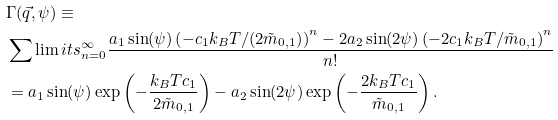<formula> <loc_0><loc_0><loc_500><loc_500>& \Gamma ( \vec { q } , \psi ) \equiv \\ & \sum \lim i t s _ { n = 0 } ^ { \infty } { \frac { { a _ { 1 } \sin ( \psi ) \left ( { - c _ { 1 } k _ { B } T / ( 2 \tilde { m } _ { 0 , 1 } ) } \right ) ^ { n } - 2 a _ { 2 } \sin ( 2 \psi ) \left ( { - 2 c _ { 1 } k _ { B } T / \tilde { m } _ { 0 , 1 } } \right ) ^ { n } } } { n ! } } \\ & = a _ { 1 } \sin ( \psi ) \exp \left ( { - \frac { k _ { B } T c _ { 1 } } { { 2 \tilde { m } _ { 0 , 1 } } } } \right ) - a _ { 2 } \sin ( 2 \psi ) \exp \left ( { - \frac { 2 k _ { B } T c _ { 1 } } { { \tilde { m } _ { 0 , 1 } } } } \right ) .</formula> 